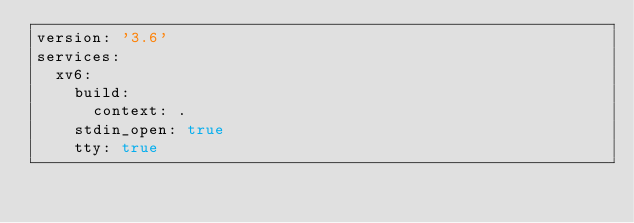<code> <loc_0><loc_0><loc_500><loc_500><_YAML_>version: '3.6'
services:
  xv6:
    build:
      context: .
    stdin_open: true
    tty: true
</code> 